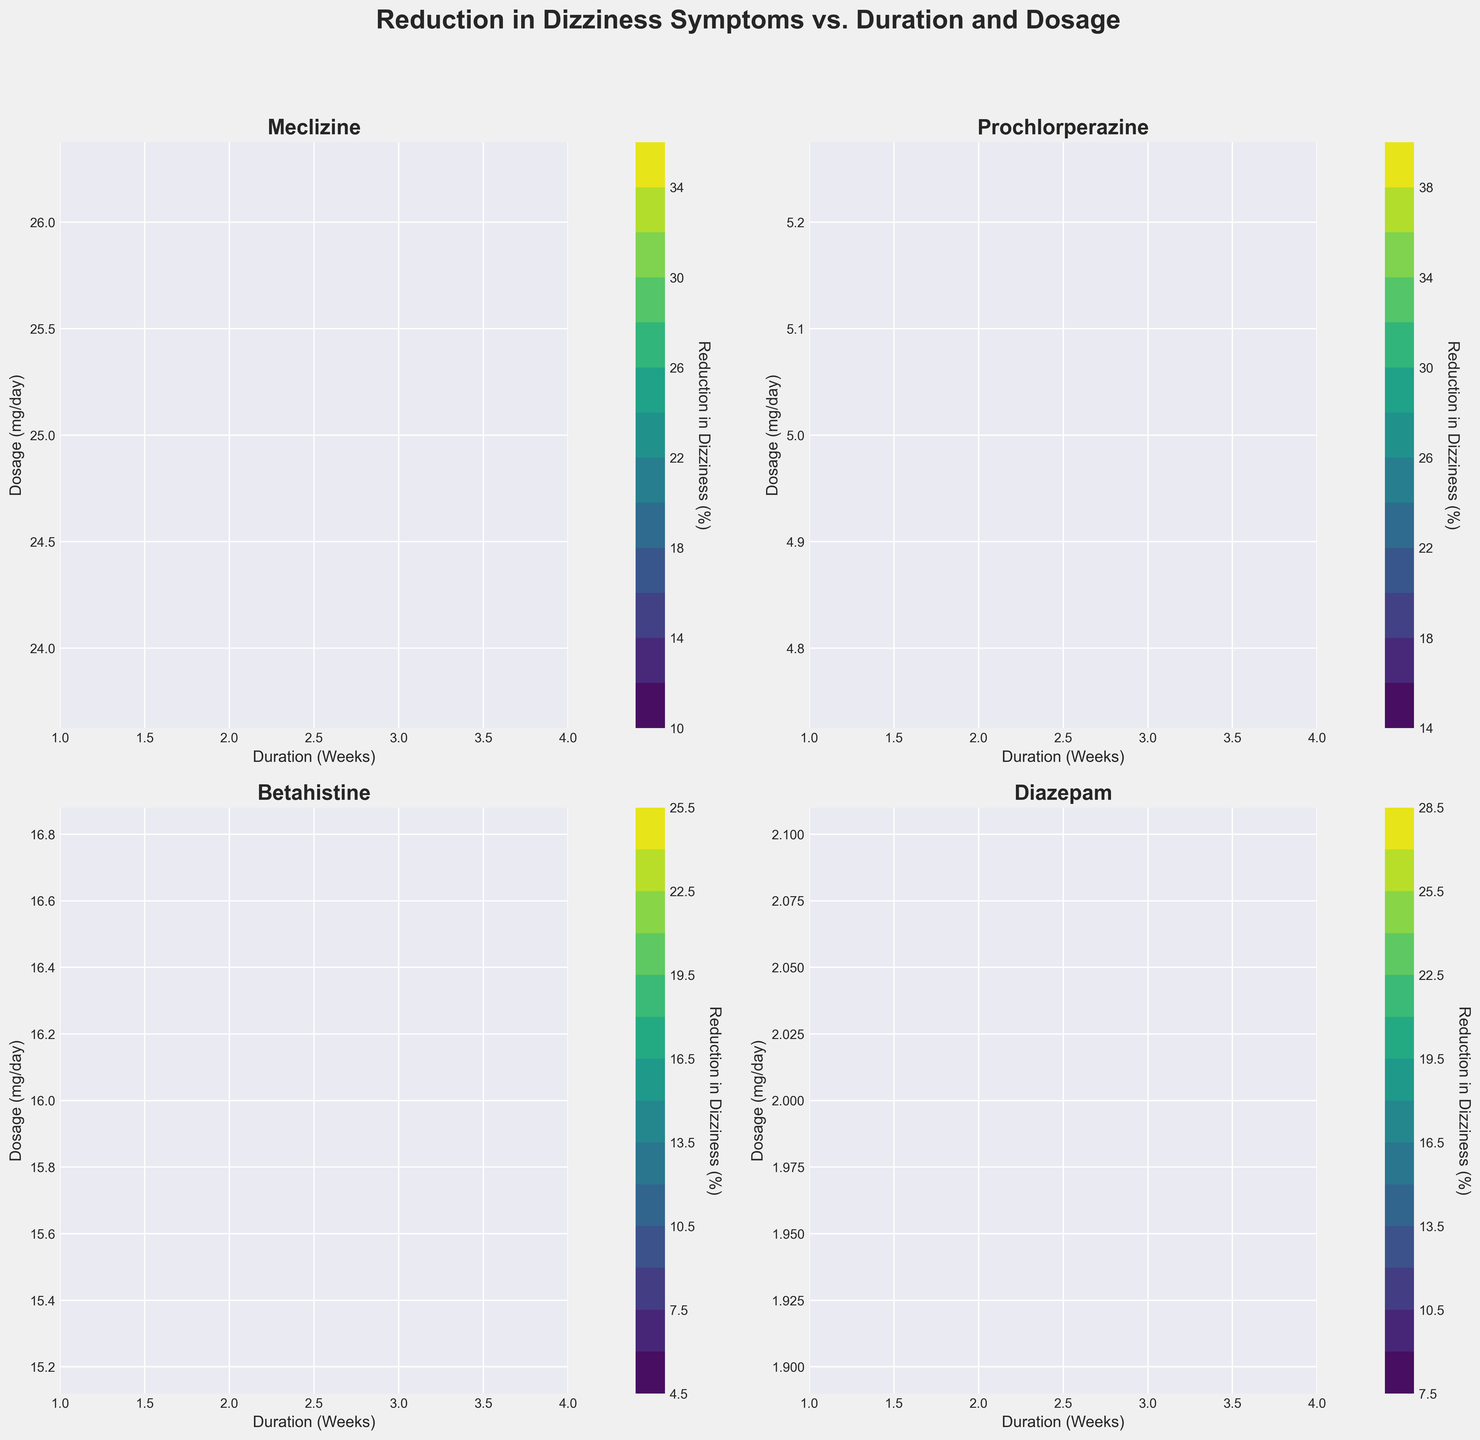What's the title of the figure? The title of the figure is displayed at the top and summarizes the focus of the entire visualization.
Answer: Reduction in Dizziness Symptoms vs. Duration and Dosage What axis labels are used for the x-axis and y-axis in each subplot? The x-axis and y-axis labels are consistent across all subplots, indicating what these dimensions represent. The x-axis is labeled 'Duration (Weeks)' and the y-axis is labeled 'Dosage (mg/day)'.
Answer: Duration (Weeks); Dosage (mg/day) Which medication shows the highest reduction in dizziness after 4 weeks? By observing the contour plots and noting the highest percentage of reduction at 4 weeks, we can determine which medication is most effective.
Answer: Prochlorperazine Is the reduction in dizziness for Meclizine better at lower, medium, or higher dosages over 4 weeks? By checking the contour plot for Meclizine across different dosages and after 4 weeks, we can see where the reduction in dizziness is the highest.
Answer: Medium dosages Which medication seems to be less effective in reducing dizziness symptoms overall? By comparing the maximum reduction percentages among all medications in their respective contour plots, we can identify the least effective one.
Answer: Betahistine How does the reduction in dizziness change with the duration of medication use for Diazepam? Observing the contour plot for Diazepam, we can see how the contours shift with increasing duration, indicating changes in reduction percentages over time.
Answer: It increases over time Which medication has a more consistent reduction in dizziness across different dosages? By examining the contour density and color gradients for each subplot, we can identify which medication maintains a more uniform reduction percentage across various dosages.
Answer: Meclizine At the 3-week mark, which medication shows the greatest improvement over its initial reduction rate? To answer this, we compare the reduction percentages at 1 week with those at 3 weeks for each medication, noting the most significant improvement.
Answer: Diazepam Does Betahistine ever reach a 30% reduction in dizziness? Looking at Betahistine's contour plot, we can identify the highest percentage of reduction it reaches and see if it ever hits 30%.
Answer: No What is the approximate reduction in dizziness for Prochlorperazine after 2 weeks at 5 mg/day dosage? By checking the contour plot for Prochlorperazine at 2 weeks and the 5 mg/day dosage level, we can find the approximate reduction percentage.
Answer: 25% 